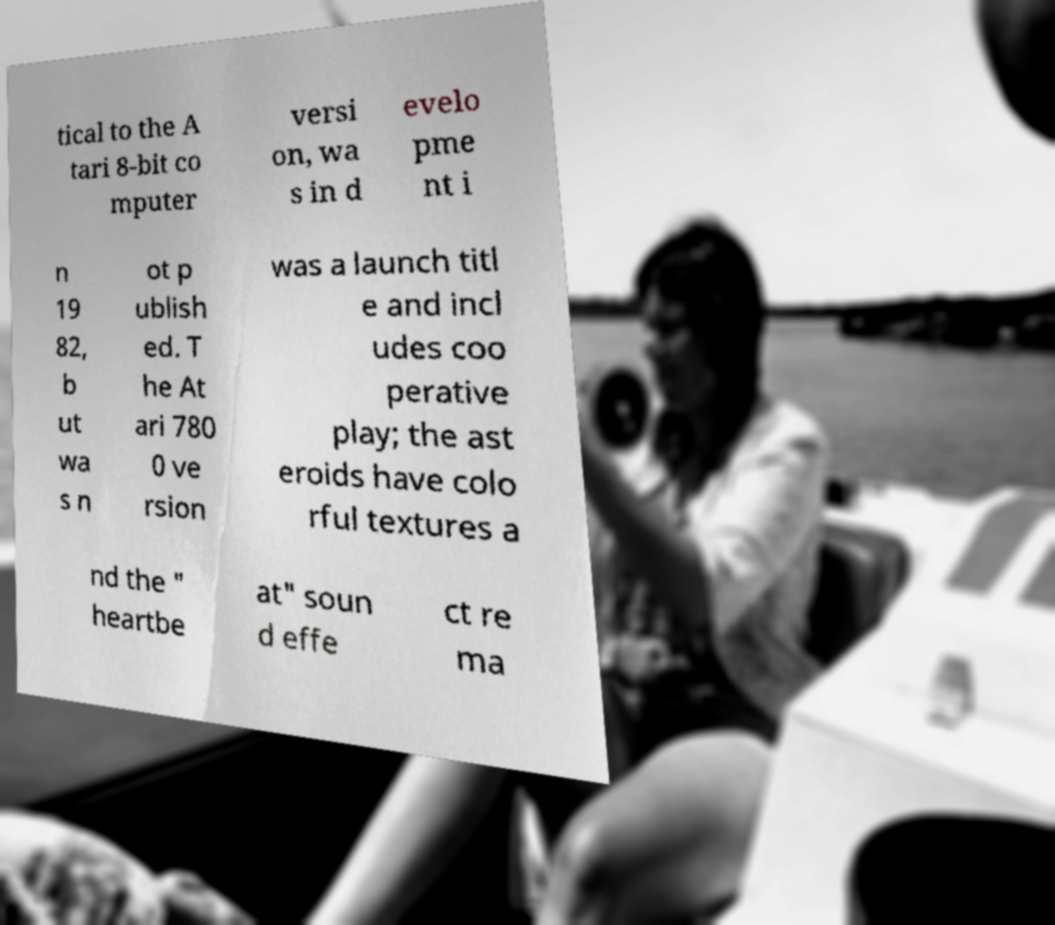Can you accurately transcribe the text from the provided image for me? tical to the A tari 8-bit co mputer versi on, wa s in d evelo pme nt i n 19 82, b ut wa s n ot p ublish ed. T he At ari 780 0 ve rsion was a launch titl e and incl udes coo perative play; the ast eroids have colo rful textures a nd the " heartbe at" soun d effe ct re ma 